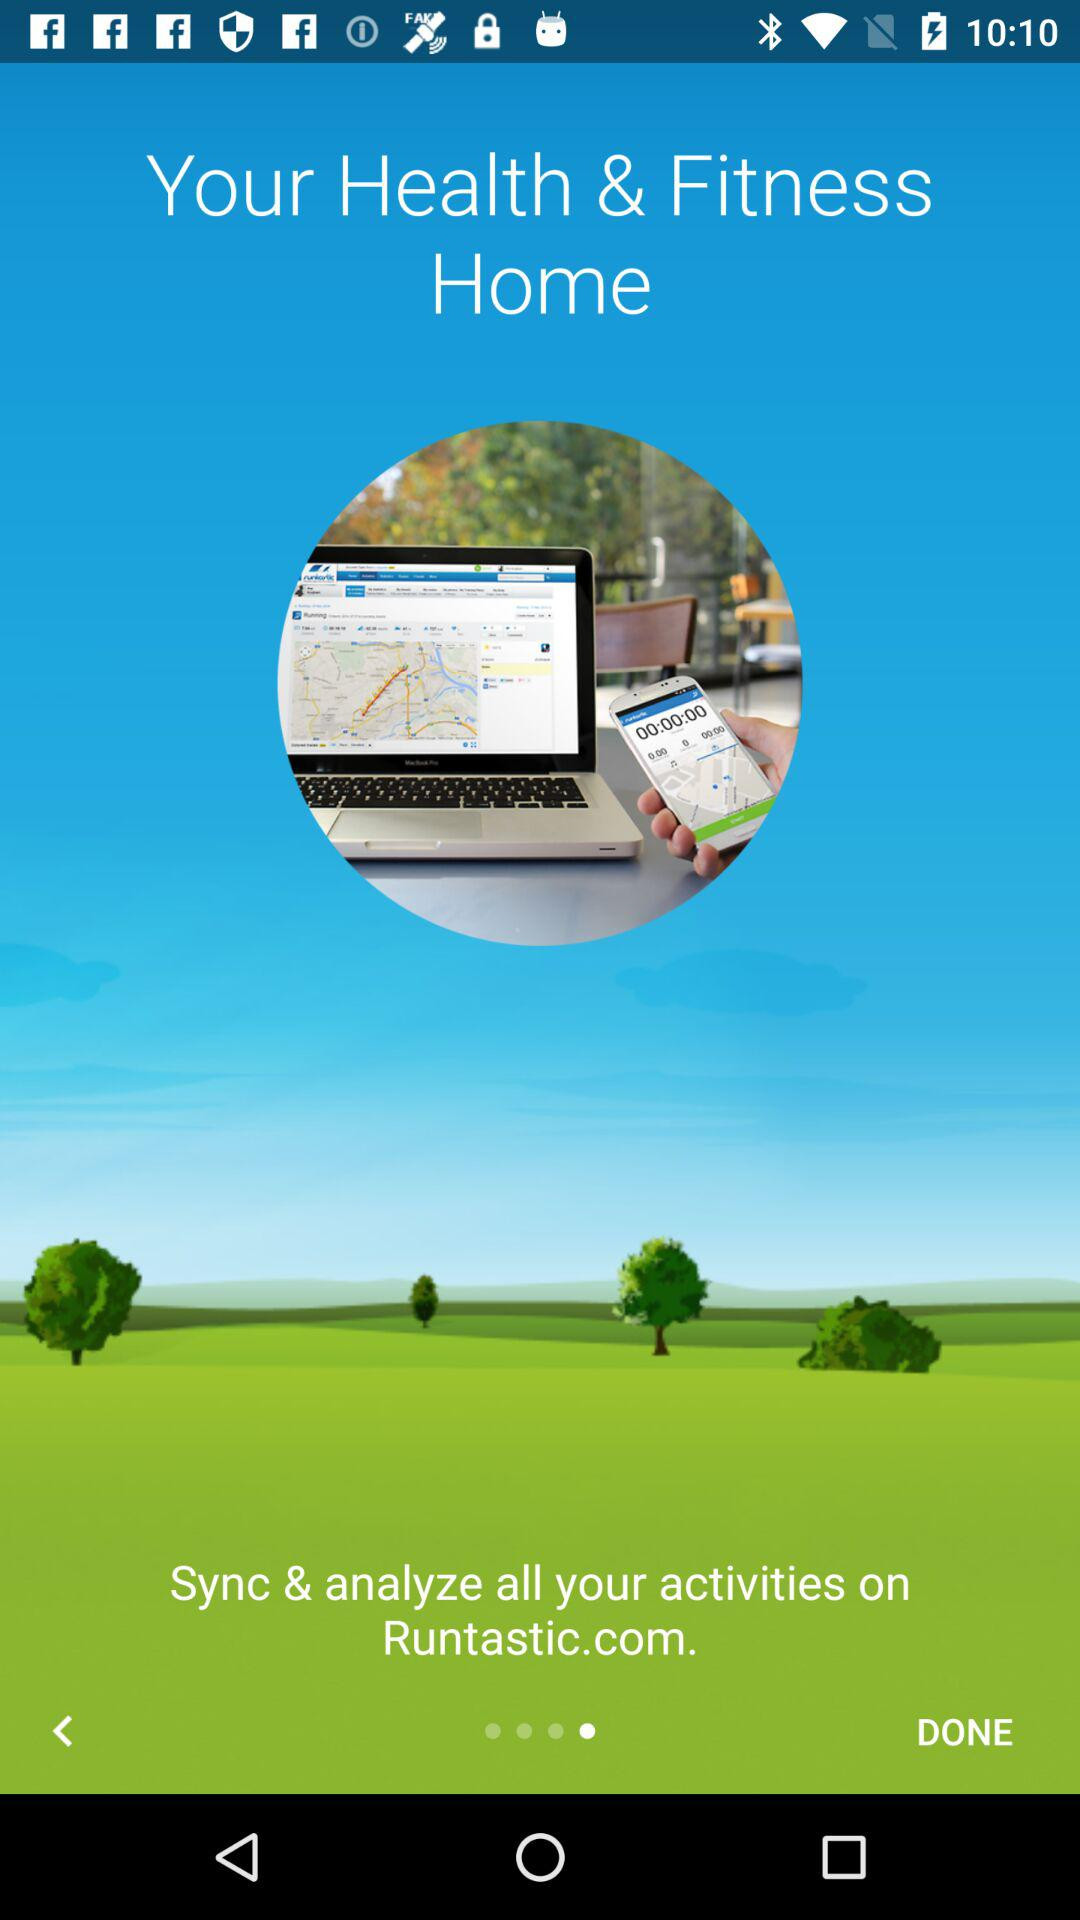On what website can we sync and analyze all our activities? You can sync and analyze all your activities on Runtastic.com. 